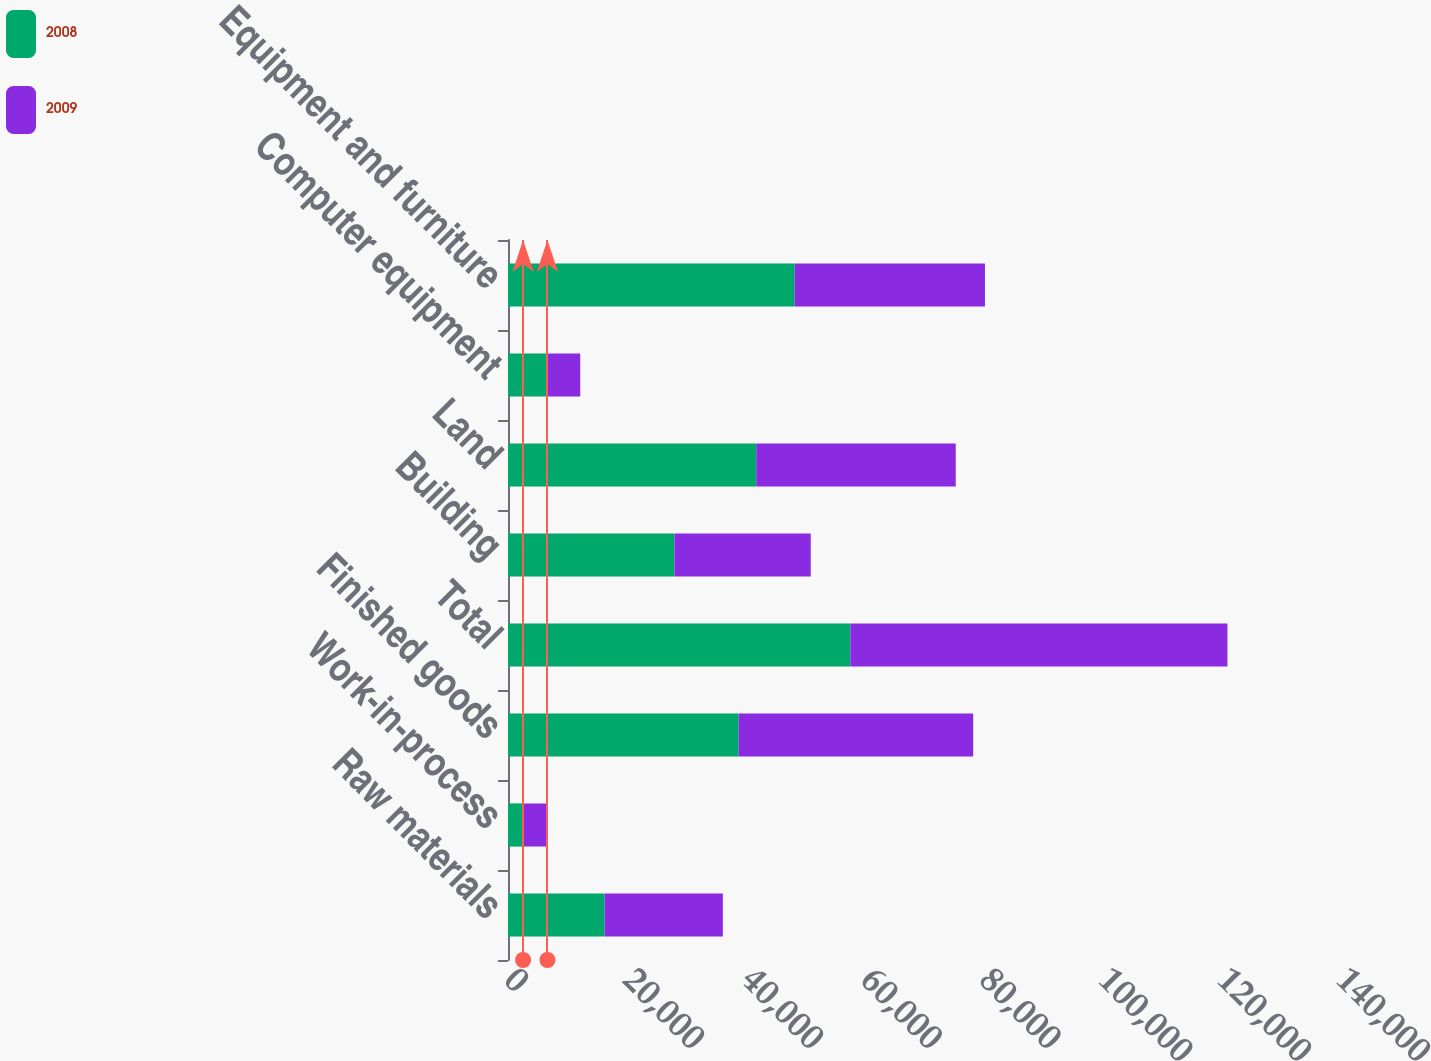<chart> <loc_0><loc_0><loc_500><loc_500><stacked_bar_chart><ecel><fcel>Raw materials<fcel>Work-in-process<fcel>Finished goods<fcel>Total<fcel>Building<fcel>Land<fcel>Computer equipment<fcel>Equipment and furniture<nl><fcel>2008<fcel>16250<fcel>2537<fcel>38813<fcel>57600<fcel>28000<fcel>41771<fcel>6555<fcel>48236<nl><fcel>2009<fcel>19901<fcel>4097<fcel>39462<fcel>63460<fcel>22944<fcel>33571<fcel>5598<fcel>32020<nl></chart> 